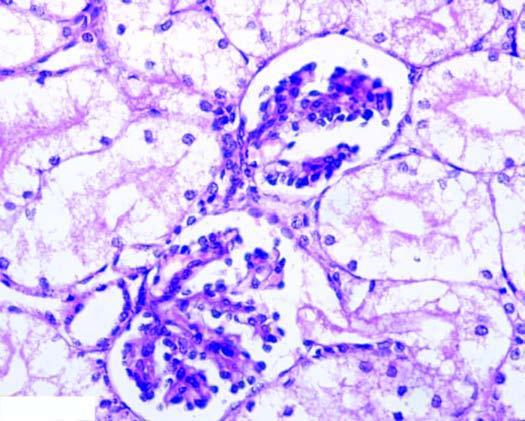what are pale?
Answer the question using a single word or phrase. The nuclei of affected tubules 